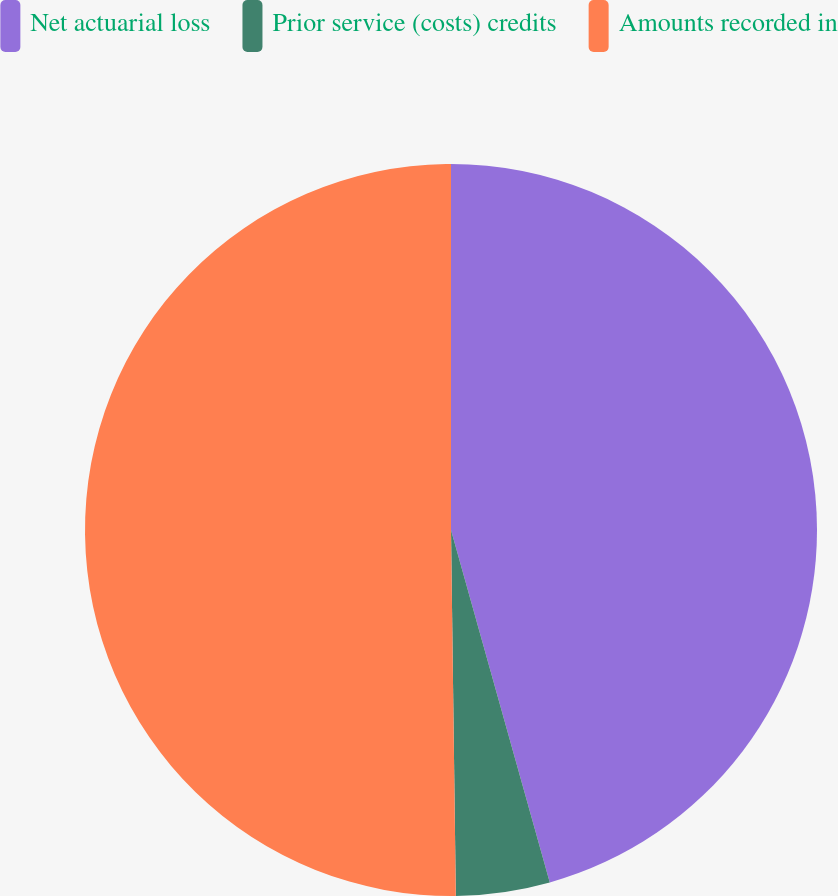<chart> <loc_0><loc_0><loc_500><loc_500><pie_chart><fcel>Net actuarial loss<fcel>Prior service (costs) credits<fcel>Amounts recorded in<nl><fcel>45.65%<fcel>4.14%<fcel>50.21%<nl></chart> 